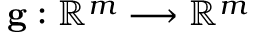Convert formula to latex. <formula><loc_0><loc_0><loc_500><loc_500>g \colon \mathbb { R } ^ { m } \longrightarrow \mathbb { R } ^ { m }</formula> 